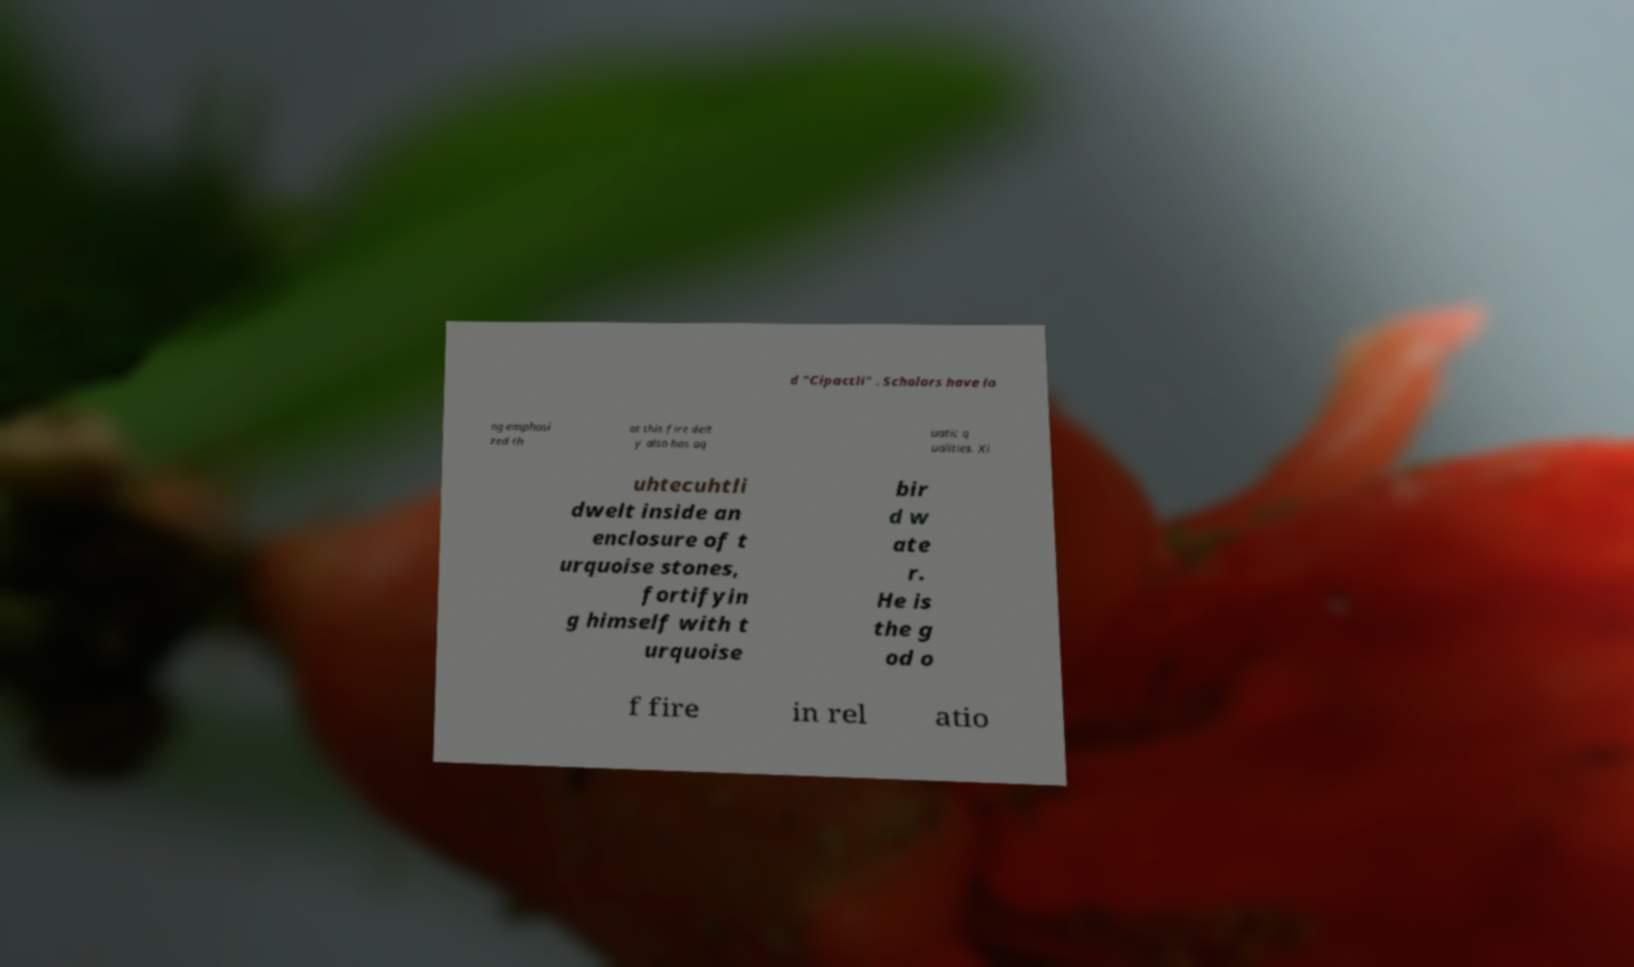Please read and relay the text visible in this image. What does it say? d "Cipactli" . Scholars have lo ng emphasi zed th at this fire deit y also has aq uatic q ualities. Xi uhtecuhtli dwelt inside an enclosure of t urquoise stones, fortifyin g himself with t urquoise bir d w ate r. He is the g od o f fire in rel atio 